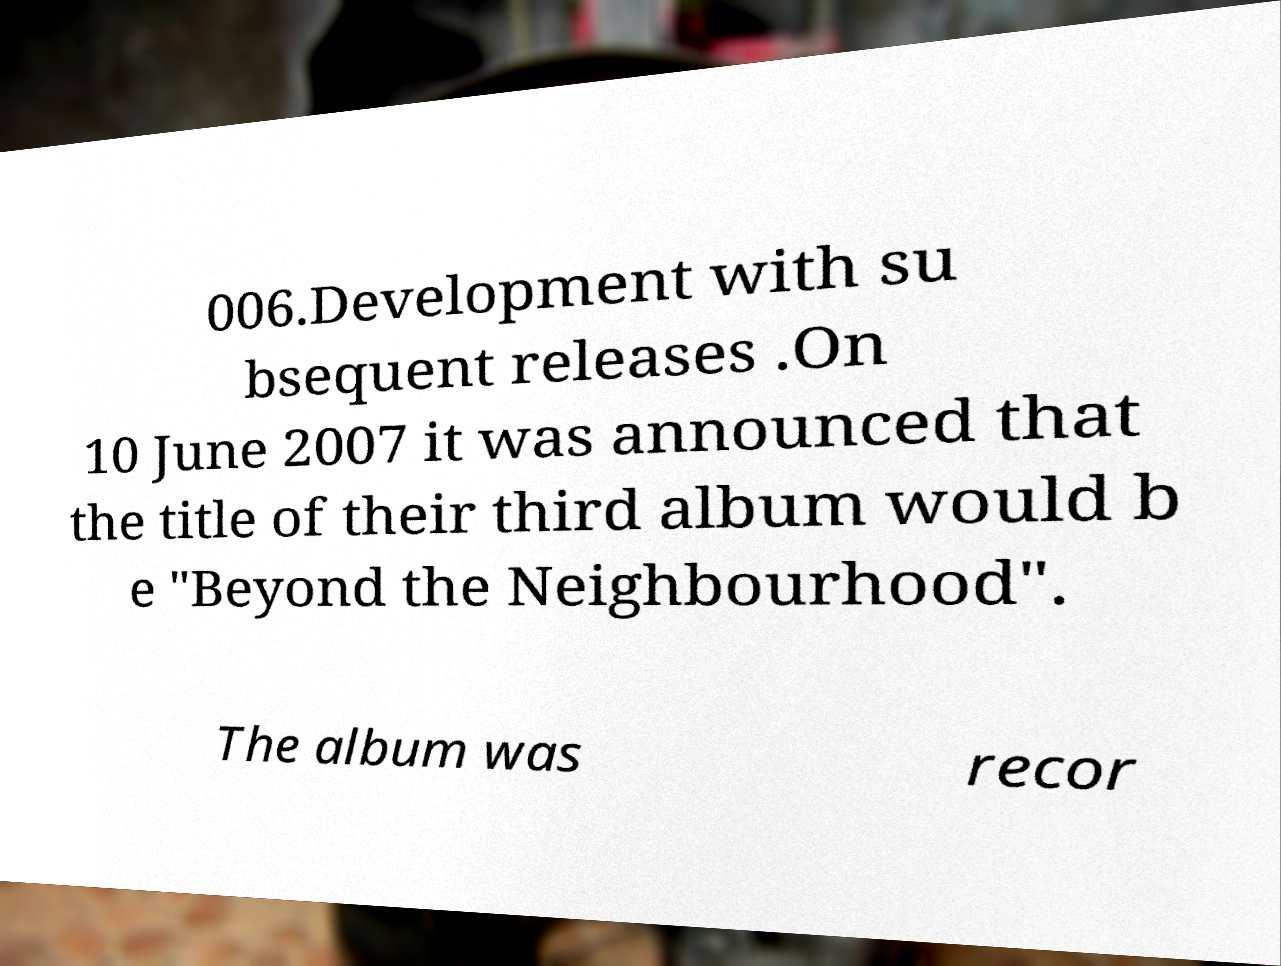Could you extract and type out the text from this image? 006.Development with su bsequent releases .On 10 June 2007 it was announced that the title of their third album would b e "Beyond the Neighbourhood". The album was recor 